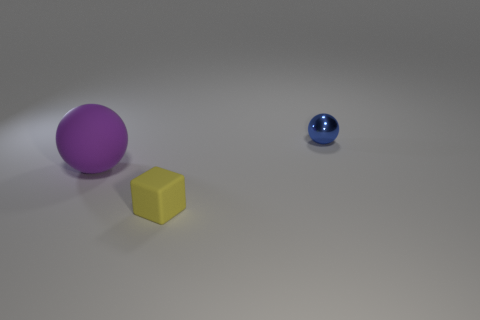Is there anything else that is the same size as the purple rubber sphere?
Your answer should be compact. No. Are there any other things that have the same material as the blue object?
Offer a very short reply. No. What size is the ball to the left of the small object in front of the tiny ball?
Your answer should be very brief. Large. There is a thing that is behind the small yellow matte thing and to the right of the big purple rubber object; what is its color?
Your response must be concise. Blue. Is the shape of the tiny shiny object the same as the big rubber thing?
Provide a succinct answer. Yes. There is a rubber object that is on the right side of the ball that is to the left of the blue ball; what is its shape?
Offer a very short reply. Cube. There is a purple object; is it the same shape as the tiny object to the right of the block?
Keep it short and to the point. Yes. The block that is the same size as the blue object is what color?
Your answer should be very brief. Yellow. Is the number of tiny yellow matte objects in front of the big purple rubber thing less than the number of tiny objects that are to the left of the tiny blue metal ball?
Make the answer very short. No. The small object that is behind the small thing that is left of the blue ball that is behind the purple matte thing is what shape?
Your answer should be compact. Sphere. 